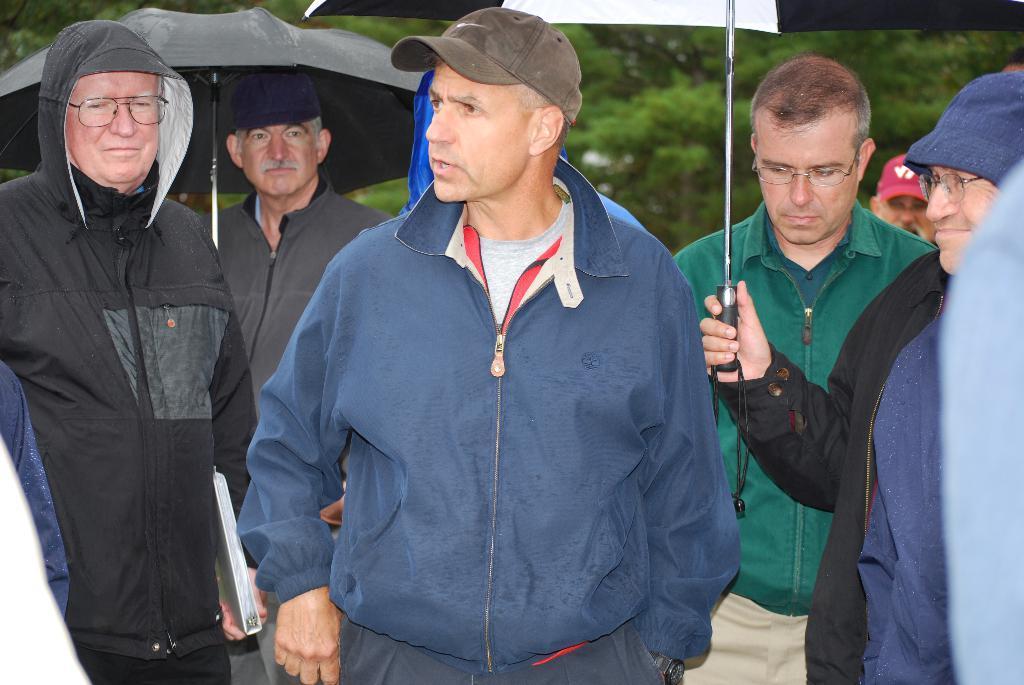In one or two sentences, can you explain what this image depicts? This picture shows few people standing and few of them wore caps on their heads and couple of them holding umbrellas in their hands and few of them wore spectacles on their faces and we see a man holding a file in his hand and all of them wore coats and we see trees on the back. 